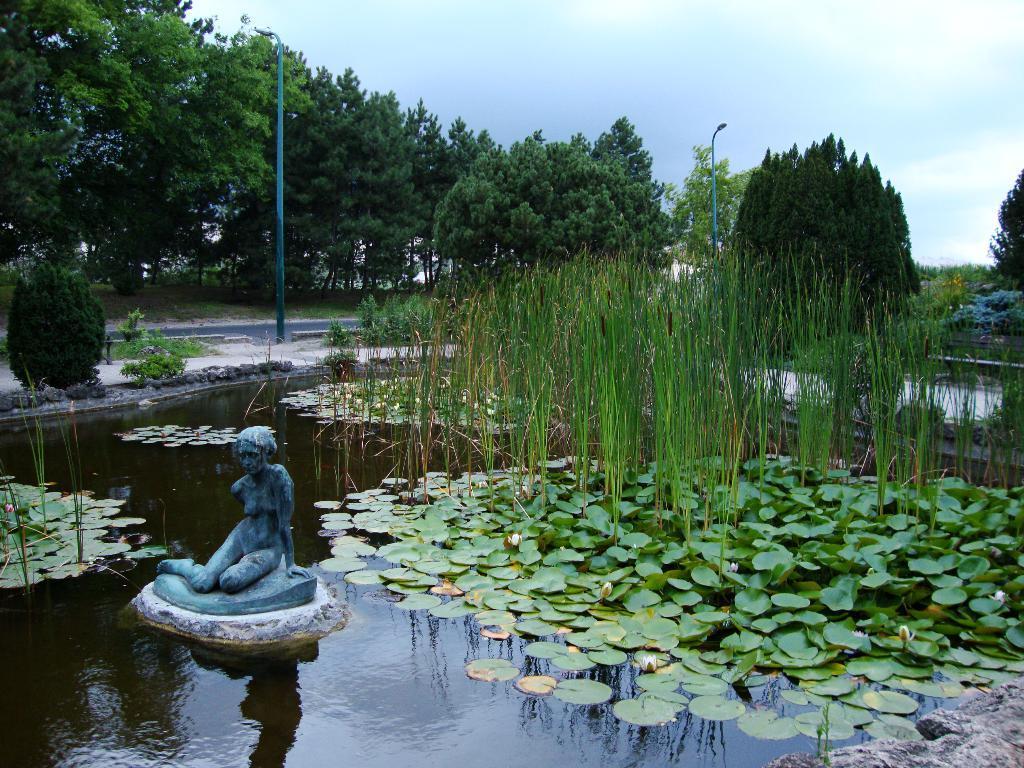Can you describe this image briefly? In this picture there is a statue near to the water. On the water we can see green leaves and grass. Beside the road we can see the street lights. In the background we can see many trees and plants. At the top we can see sky and clouds. 